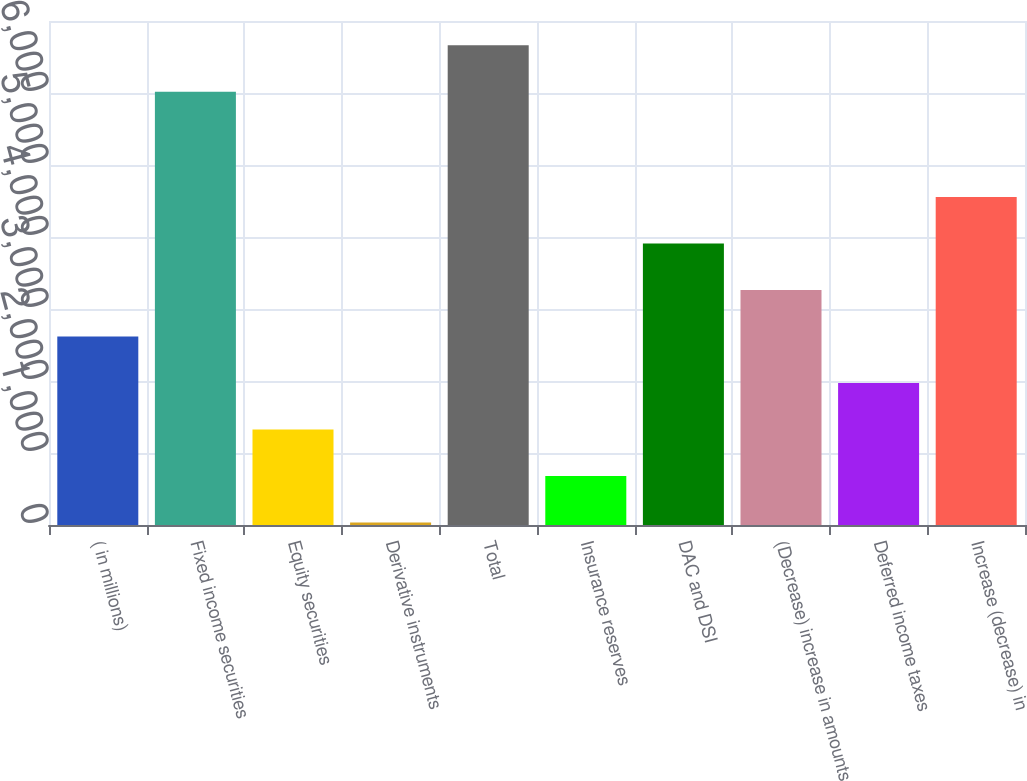Convert chart. <chart><loc_0><loc_0><loc_500><loc_500><bar_chart><fcel>( in millions)<fcel>Fixed income securities<fcel>Equity securities<fcel>Derivative instruments<fcel>Total<fcel>Insurance reserves<fcel>DAC and DSI<fcel>(Decrease) increase in amounts<fcel>Deferred income taxes<fcel>Increase (decrease) in<nl><fcel>2617.6<fcel>6019<fcel>1325.8<fcel>34<fcel>6664.9<fcel>679.9<fcel>3909.4<fcel>3263.5<fcel>1971.7<fcel>4555.3<nl></chart> 